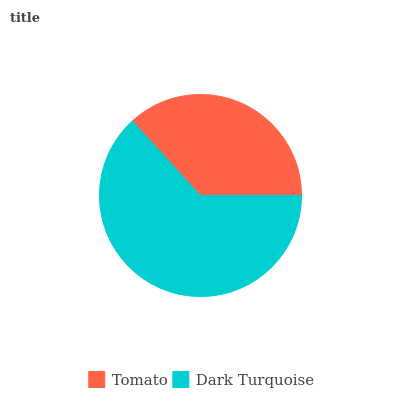Is Tomato the minimum?
Answer yes or no. Yes. Is Dark Turquoise the maximum?
Answer yes or no. Yes. Is Dark Turquoise the minimum?
Answer yes or no. No. Is Dark Turquoise greater than Tomato?
Answer yes or no. Yes. Is Tomato less than Dark Turquoise?
Answer yes or no. Yes. Is Tomato greater than Dark Turquoise?
Answer yes or no. No. Is Dark Turquoise less than Tomato?
Answer yes or no. No. Is Dark Turquoise the high median?
Answer yes or no. Yes. Is Tomato the low median?
Answer yes or no. Yes. Is Tomato the high median?
Answer yes or no. No. Is Dark Turquoise the low median?
Answer yes or no. No. 